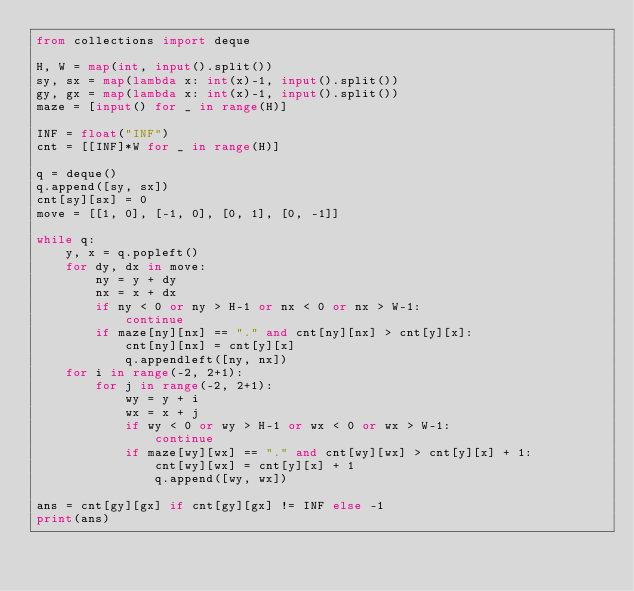Convert code to text. <code><loc_0><loc_0><loc_500><loc_500><_Python_>from collections import deque

H, W = map(int, input().split())
sy, sx = map(lambda x: int(x)-1, input().split())
gy, gx = map(lambda x: int(x)-1, input().split())
maze = [input() for _ in range(H)]

INF = float("INF")
cnt = [[INF]*W for _ in range(H)]

q = deque()
q.append([sy, sx])
cnt[sy][sx] = 0
move = [[1, 0], [-1, 0], [0, 1], [0, -1]]

while q:
    y, x = q.popleft()
    for dy, dx in move:
        ny = y + dy
        nx = x + dx
        if ny < 0 or ny > H-1 or nx < 0 or nx > W-1:
            continue
        if maze[ny][nx] == "." and cnt[ny][nx] > cnt[y][x]:
            cnt[ny][nx] = cnt[y][x]
            q.appendleft([ny, nx])
    for i in range(-2, 2+1):
        for j in range(-2, 2+1):
            wy = y + i
            wx = x + j
            if wy < 0 or wy > H-1 or wx < 0 or wx > W-1:
                continue
            if maze[wy][wx] == "." and cnt[wy][wx] > cnt[y][x] + 1:
                cnt[wy][wx] = cnt[y][x] + 1
                q.append([wy, wx])

ans = cnt[gy][gx] if cnt[gy][gx] != INF else -1
print(ans)</code> 